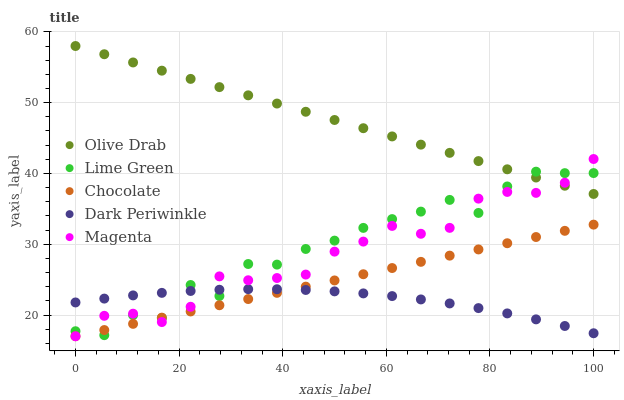Does Dark Periwinkle have the minimum area under the curve?
Answer yes or no. Yes. Does Olive Drab have the maximum area under the curve?
Answer yes or no. Yes. Does Lime Green have the minimum area under the curve?
Answer yes or no. No. Does Lime Green have the maximum area under the curve?
Answer yes or no. No. Is Chocolate the smoothest?
Answer yes or no. Yes. Is Lime Green the roughest?
Answer yes or no. Yes. Is Dark Periwinkle the smoothest?
Answer yes or no. No. Is Dark Periwinkle the roughest?
Answer yes or no. No. Does Magenta have the lowest value?
Answer yes or no. Yes. Does Lime Green have the lowest value?
Answer yes or no. No. Does Olive Drab have the highest value?
Answer yes or no. Yes. Does Lime Green have the highest value?
Answer yes or no. No. Is Chocolate less than Olive Drab?
Answer yes or no. Yes. Is Olive Drab greater than Chocolate?
Answer yes or no. Yes. Does Magenta intersect Dark Periwinkle?
Answer yes or no. Yes. Is Magenta less than Dark Periwinkle?
Answer yes or no. No. Is Magenta greater than Dark Periwinkle?
Answer yes or no. No. Does Chocolate intersect Olive Drab?
Answer yes or no. No. 